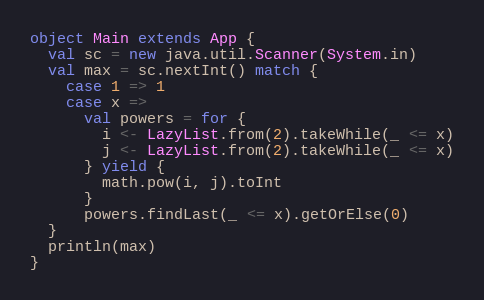Convert code to text. <code><loc_0><loc_0><loc_500><loc_500><_Scala_>object Main extends App {
  val sc = new java.util.Scanner(System.in)
  val max = sc.nextInt() match {
    case 1 => 1
    case x =>
      val powers = for {
        i <- LazyList.from(2).takeWhile(_ <= x)
        j <- LazyList.from(2).takeWhile(_ <= x)
      } yield {
        math.pow(i, j).toInt
      }
      powers.findLast(_ <= x).getOrElse(0)
  }
  println(max)
}
</code> 